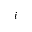<formula> <loc_0><loc_0><loc_500><loc_500>i</formula> 